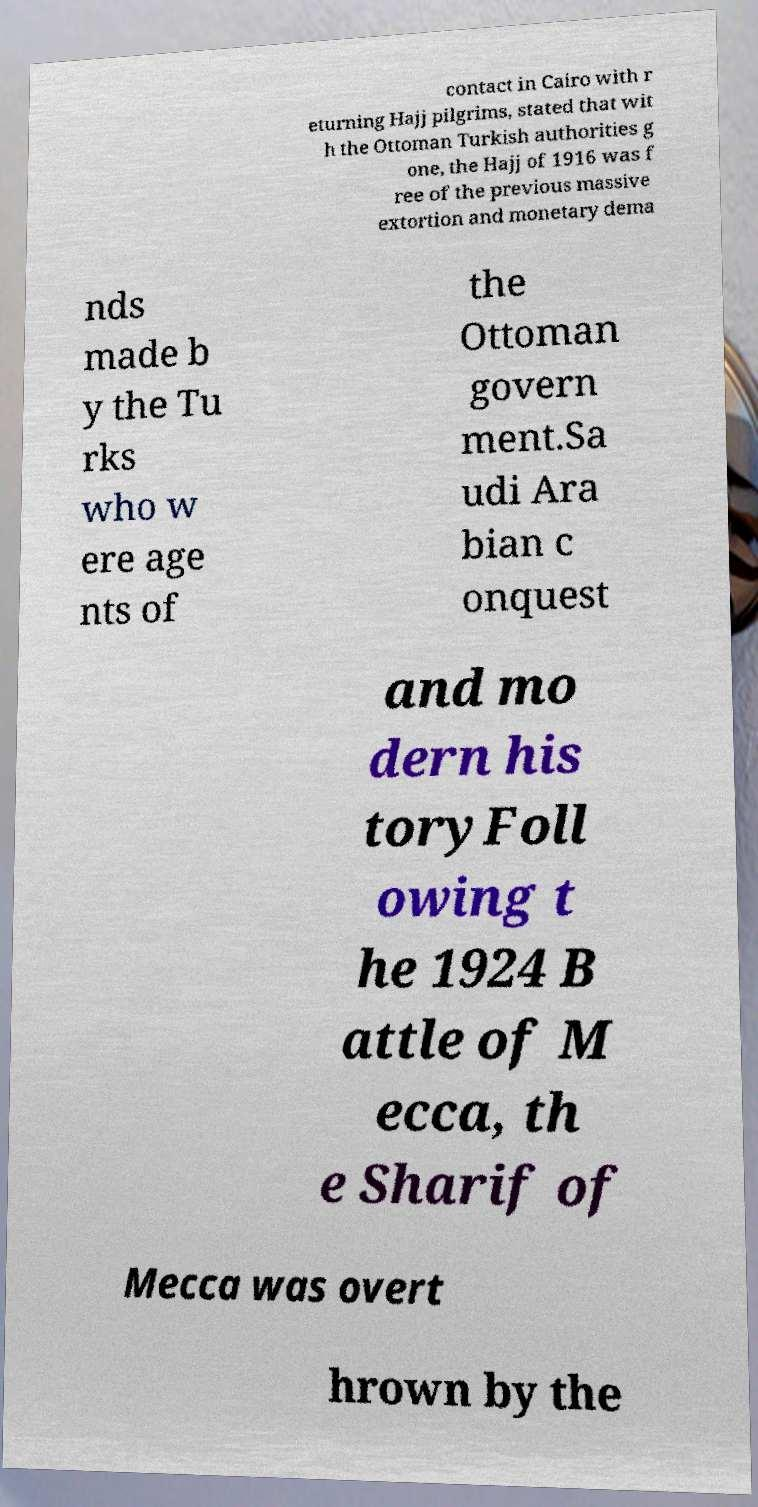There's text embedded in this image that I need extracted. Can you transcribe it verbatim? contact in Cairo with r eturning Hajj pilgrims, stated that wit h the Ottoman Turkish authorities g one, the Hajj of 1916 was f ree of the previous massive extortion and monetary dema nds made b y the Tu rks who w ere age nts of the Ottoman govern ment.Sa udi Ara bian c onquest and mo dern his toryFoll owing t he 1924 B attle of M ecca, th e Sharif of Mecca was overt hrown by the 